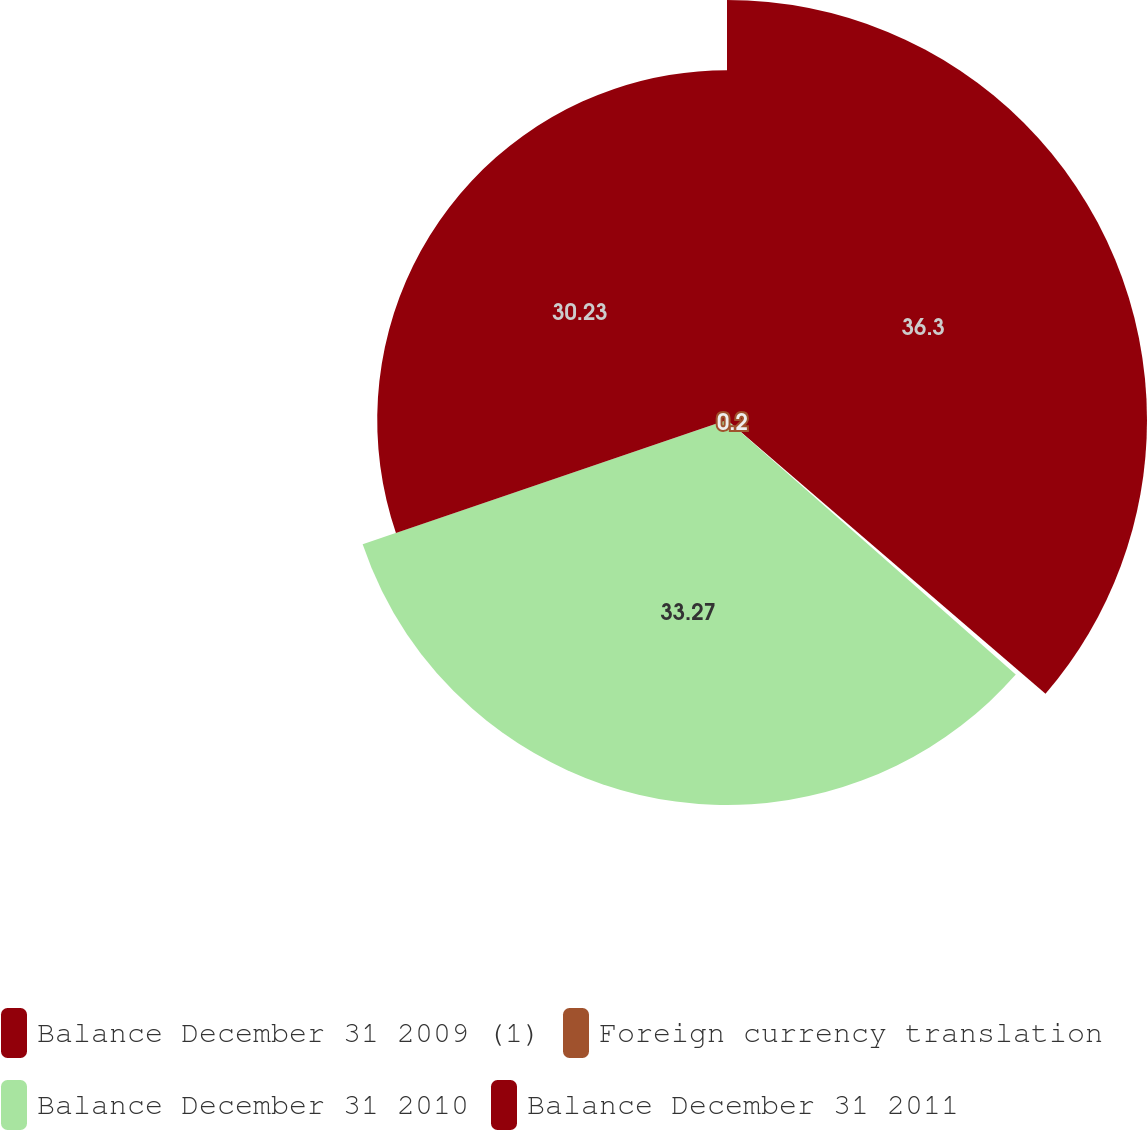Convert chart. <chart><loc_0><loc_0><loc_500><loc_500><pie_chart><fcel>Balance December 31 2009 (1)<fcel>Foreign currency translation<fcel>Balance December 31 2010<fcel>Balance December 31 2011<nl><fcel>36.3%<fcel>0.2%<fcel>33.27%<fcel>30.23%<nl></chart> 